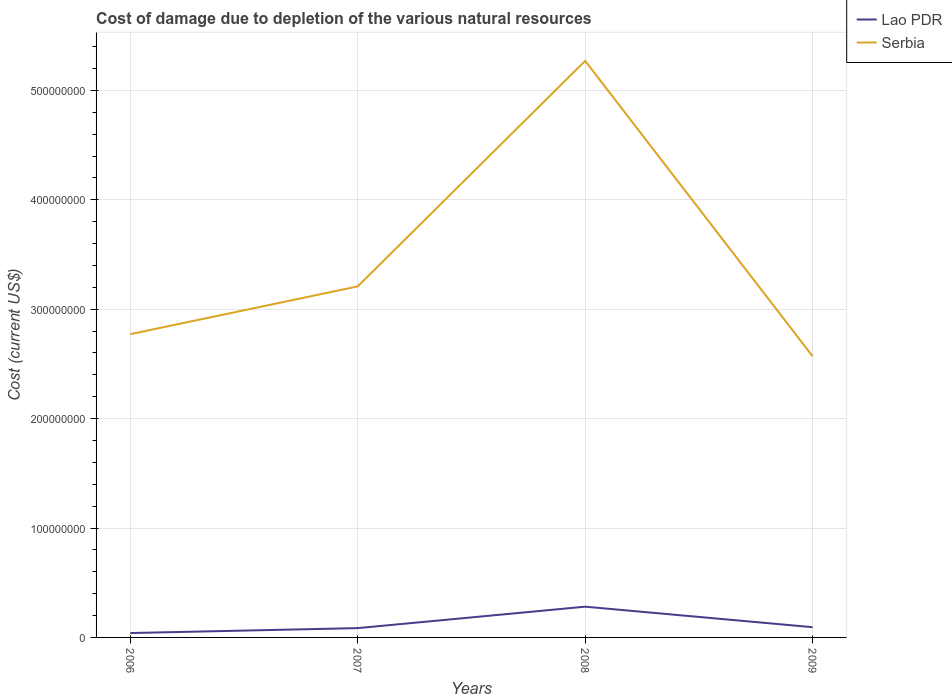Does the line corresponding to Serbia intersect with the line corresponding to Lao PDR?
Offer a terse response. No. Is the number of lines equal to the number of legend labels?
Provide a succinct answer. Yes. Across all years, what is the maximum cost of damage caused due to the depletion of various natural resources in Serbia?
Provide a succinct answer. 2.57e+08. In which year was the cost of damage caused due to the depletion of various natural resources in Lao PDR maximum?
Offer a very short reply. 2006. What is the total cost of damage caused due to the depletion of various natural resources in Lao PDR in the graph?
Your answer should be very brief. -2.41e+07. What is the difference between the highest and the second highest cost of damage caused due to the depletion of various natural resources in Serbia?
Your response must be concise. 2.70e+08. Is the cost of damage caused due to the depletion of various natural resources in Serbia strictly greater than the cost of damage caused due to the depletion of various natural resources in Lao PDR over the years?
Your answer should be compact. No. How many lines are there?
Offer a terse response. 2. Does the graph contain grids?
Provide a succinct answer. Yes. How many legend labels are there?
Make the answer very short. 2. How are the legend labels stacked?
Make the answer very short. Vertical. What is the title of the graph?
Offer a terse response. Cost of damage due to depletion of the various natural resources. Does "Benin" appear as one of the legend labels in the graph?
Keep it short and to the point. No. What is the label or title of the X-axis?
Make the answer very short. Years. What is the label or title of the Y-axis?
Your response must be concise. Cost (current US$). What is the Cost (current US$) in Lao PDR in 2006?
Provide a succinct answer. 4.01e+06. What is the Cost (current US$) of Serbia in 2006?
Give a very brief answer. 2.77e+08. What is the Cost (current US$) in Lao PDR in 2007?
Your answer should be very brief. 8.51e+06. What is the Cost (current US$) of Serbia in 2007?
Provide a short and direct response. 3.21e+08. What is the Cost (current US$) in Lao PDR in 2008?
Your response must be concise. 2.81e+07. What is the Cost (current US$) in Serbia in 2008?
Ensure brevity in your answer.  5.27e+08. What is the Cost (current US$) of Lao PDR in 2009?
Your response must be concise. 9.36e+06. What is the Cost (current US$) in Serbia in 2009?
Provide a short and direct response. 2.57e+08. Across all years, what is the maximum Cost (current US$) in Lao PDR?
Keep it short and to the point. 2.81e+07. Across all years, what is the maximum Cost (current US$) in Serbia?
Your answer should be very brief. 5.27e+08. Across all years, what is the minimum Cost (current US$) of Lao PDR?
Your answer should be very brief. 4.01e+06. Across all years, what is the minimum Cost (current US$) of Serbia?
Make the answer very short. 2.57e+08. What is the total Cost (current US$) of Lao PDR in the graph?
Your response must be concise. 5.00e+07. What is the total Cost (current US$) in Serbia in the graph?
Provide a short and direct response. 1.38e+09. What is the difference between the Cost (current US$) in Lao PDR in 2006 and that in 2007?
Ensure brevity in your answer.  -4.50e+06. What is the difference between the Cost (current US$) in Serbia in 2006 and that in 2007?
Your answer should be very brief. -4.37e+07. What is the difference between the Cost (current US$) of Lao PDR in 2006 and that in 2008?
Offer a very short reply. -2.41e+07. What is the difference between the Cost (current US$) in Serbia in 2006 and that in 2008?
Give a very brief answer. -2.50e+08. What is the difference between the Cost (current US$) in Lao PDR in 2006 and that in 2009?
Your response must be concise. -5.36e+06. What is the difference between the Cost (current US$) of Serbia in 2006 and that in 2009?
Give a very brief answer. 2.02e+07. What is the difference between the Cost (current US$) of Lao PDR in 2007 and that in 2008?
Offer a terse response. -1.96e+07. What is the difference between the Cost (current US$) in Serbia in 2007 and that in 2008?
Provide a short and direct response. -2.06e+08. What is the difference between the Cost (current US$) of Lao PDR in 2007 and that in 2009?
Provide a succinct answer. -8.51e+05. What is the difference between the Cost (current US$) in Serbia in 2007 and that in 2009?
Your answer should be compact. 6.39e+07. What is the difference between the Cost (current US$) of Lao PDR in 2008 and that in 2009?
Your answer should be compact. 1.87e+07. What is the difference between the Cost (current US$) in Serbia in 2008 and that in 2009?
Keep it short and to the point. 2.70e+08. What is the difference between the Cost (current US$) of Lao PDR in 2006 and the Cost (current US$) of Serbia in 2007?
Your response must be concise. -3.17e+08. What is the difference between the Cost (current US$) in Lao PDR in 2006 and the Cost (current US$) in Serbia in 2008?
Your answer should be compact. -5.23e+08. What is the difference between the Cost (current US$) of Lao PDR in 2006 and the Cost (current US$) of Serbia in 2009?
Your answer should be very brief. -2.53e+08. What is the difference between the Cost (current US$) in Lao PDR in 2007 and the Cost (current US$) in Serbia in 2008?
Offer a very short reply. -5.19e+08. What is the difference between the Cost (current US$) of Lao PDR in 2007 and the Cost (current US$) of Serbia in 2009?
Your answer should be very brief. -2.48e+08. What is the difference between the Cost (current US$) in Lao PDR in 2008 and the Cost (current US$) in Serbia in 2009?
Ensure brevity in your answer.  -2.29e+08. What is the average Cost (current US$) of Lao PDR per year?
Provide a short and direct response. 1.25e+07. What is the average Cost (current US$) in Serbia per year?
Offer a terse response. 3.46e+08. In the year 2006, what is the difference between the Cost (current US$) in Lao PDR and Cost (current US$) in Serbia?
Offer a very short reply. -2.73e+08. In the year 2007, what is the difference between the Cost (current US$) of Lao PDR and Cost (current US$) of Serbia?
Give a very brief answer. -3.12e+08. In the year 2008, what is the difference between the Cost (current US$) in Lao PDR and Cost (current US$) in Serbia?
Keep it short and to the point. -4.99e+08. In the year 2009, what is the difference between the Cost (current US$) of Lao PDR and Cost (current US$) of Serbia?
Make the answer very short. -2.48e+08. What is the ratio of the Cost (current US$) in Lao PDR in 2006 to that in 2007?
Offer a terse response. 0.47. What is the ratio of the Cost (current US$) in Serbia in 2006 to that in 2007?
Your response must be concise. 0.86. What is the ratio of the Cost (current US$) in Lao PDR in 2006 to that in 2008?
Offer a terse response. 0.14. What is the ratio of the Cost (current US$) of Serbia in 2006 to that in 2008?
Offer a very short reply. 0.53. What is the ratio of the Cost (current US$) in Lao PDR in 2006 to that in 2009?
Offer a very short reply. 0.43. What is the ratio of the Cost (current US$) of Serbia in 2006 to that in 2009?
Make the answer very short. 1.08. What is the ratio of the Cost (current US$) in Lao PDR in 2007 to that in 2008?
Your answer should be very brief. 0.3. What is the ratio of the Cost (current US$) in Serbia in 2007 to that in 2008?
Your answer should be compact. 0.61. What is the ratio of the Cost (current US$) in Lao PDR in 2007 to that in 2009?
Offer a terse response. 0.91. What is the ratio of the Cost (current US$) of Serbia in 2007 to that in 2009?
Make the answer very short. 1.25. What is the ratio of the Cost (current US$) of Lao PDR in 2008 to that in 2009?
Your response must be concise. 3. What is the ratio of the Cost (current US$) of Serbia in 2008 to that in 2009?
Your answer should be very brief. 2.05. What is the difference between the highest and the second highest Cost (current US$) in Lao PDR?
Make the answer very short. 1.87e+07. What is the difference between the highest and the second highest Cost (current US$) in Serbia?
Make the answer very short. 2.06e+08. What is the difference between the highest and the lowest Cost (current US$) of Lao PDR?
Your answer should be very brief. 2.41e+07. What is the difference between the highest and the lowest Cost (current US$) in Serbia?
Provide a short and direct response. 2.70e+08. 